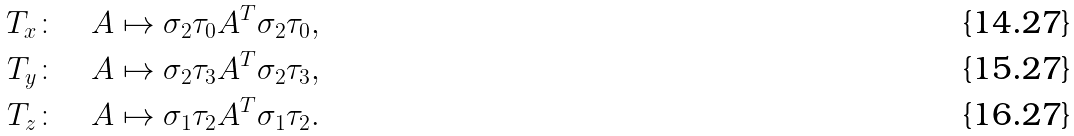<formula> <loc_0><loc_0><loc_500><loc_500>T _ { x } \colon & \quad A \mapsto \sigma _ { 2 } \tau _ { 0 } A ^ { T } \sigma _ { 2 } \tau _ { 0 } , \\ T _ { y } \colon & \quad A \mapsto \sigma _ { 2 } \tau _ { 3 } A ^ { T } \sigma _ { 2 } \tau _ { 3 } , \\ T _ { z } \colon & \quad A \mapsto \sigma _ { 1 } \tau _ { 2 } A ^ { T } \sigma _ { 1 } \tau _ { 2 } .</formula> 